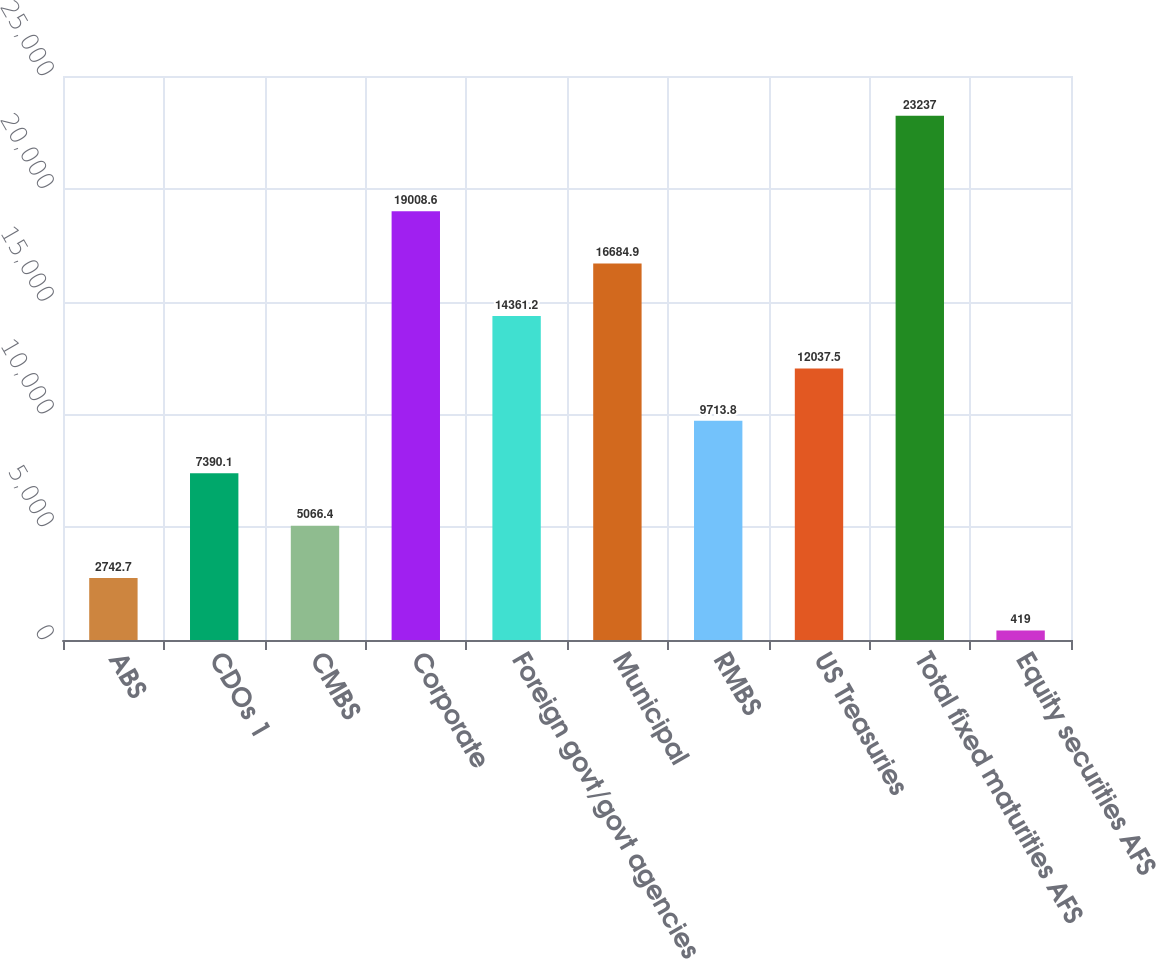Convert chart to OTSL. <chart><loc_0><loc_0><loc_500><loc_500><bar_chart><fcel>ABS<fcel>CDOs 1<fcel>CMBS<fcel>Corporate<fcel>Foreign govt/govt agencies<fcel>Municipal<fcel>RMBS<fcel>US Treasuries<fcel>Total fixed maturities AFS<fcel>Equity securities AFS<nl><fcel>2742.7<fcel>7390.1<fcel>5066.4<fcel>19008.6<fcel>14361.2<fcel>16684.9<fcel>9713.8<fcel>12037.5<fcel>23237<fcel>419<nl></chart> 